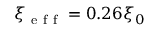Convert formula to latex. <formula><loc_0><loc_0><loc_500><loc_500>\xi _ { e f f } = 0 . 2 6 \xi _ { 0 }</formula> 